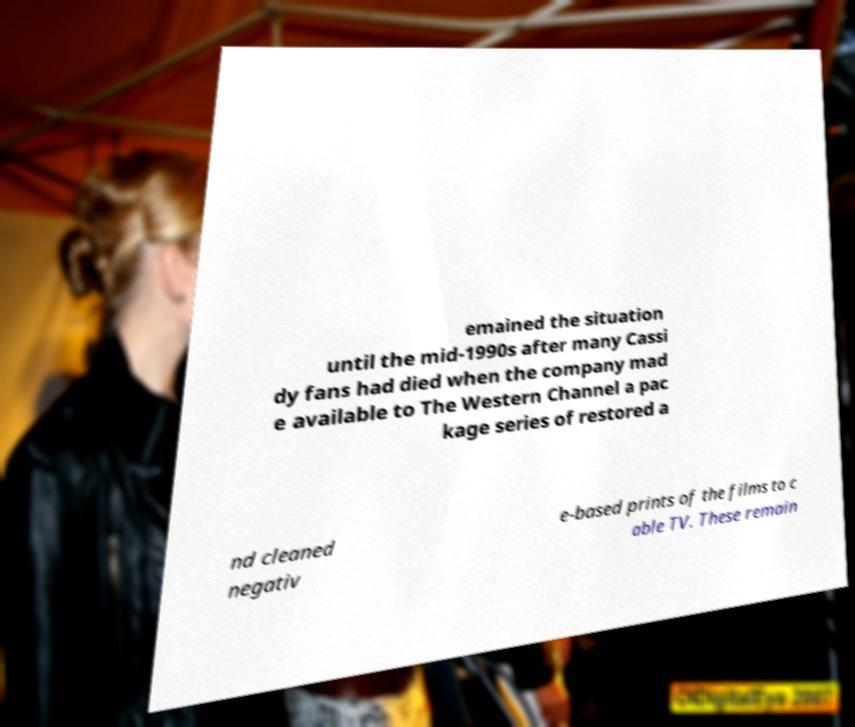Please identify and transcribe the text found in this image. emained the situation until the mid-1990s after many Cassi dy fans had died when the company mad e available to The Western Channel a pac kage series of restored a nd cleaned negativ e-based prints of the films to c able TV. These remain 